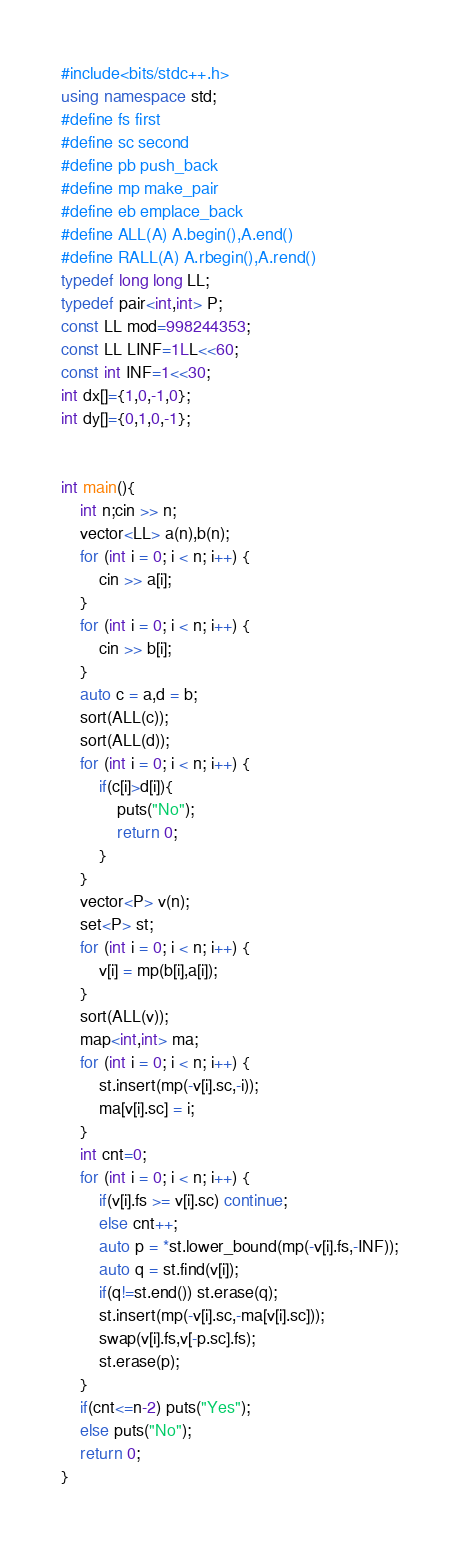<code> <loc_0><loc_0><loc_500><loc_500><_C++_>#include<bits/stdc++.h>
using namespace std;
#define fs first
#define sc second
#define pb push_back
#define mp make_pair
#define eb emplace_back
#define ALL(A) A.begin(),A.end()
#define RALL(A) A.rbegin(),A.rend()
typedef long long LL;
typedef pair<int,int> P;
const LL mod=998244353;
const LL LINF=1LL<<60;
const int INF=1<<30;
int dx[]={1,0,-1,0};
int dy[]={0,1,0,-1};


int main(){
    int n;cin >> n;
    vector<LL> a(n),b(n);
    for (int i = 0; i < n; i++) {
        cin >> a[i];
    }
    for (int i = 0; i < n; i++) {
        cin >> b[i];
    }
    auto c = a,d = b;
    sort(ALL(c));
    sort(ALL(d));
    for (int i = 0; i < n; i++) {
        if(c[i]>d[i]){
            puts("No");
            return 0;
        }
    }
    vector<P> v(n);
    set<P> st;
    for (int i = 0; i < n; i++) {
        v[i] = mp(b[i],a[i]);
    }
    sort(ALL(v));
    map<int,int> ma;
    for (int i = 0; i < n; i++) {
        st.insert(mp(-v[i].sc,-i));
        ma[v[i].sc] = i;
    }
    int cnt=0;
    for (int i = 0; i < n; i++) {
        if(v[i].fs >= v[i].sc) continue;
        else cnt++;
        auto p = *st.lower_bound(mp(-v[i].fs,-INF));
        auto q = st.find(v[i]);
        if(q!=st.end()) st.erase(q);
        st.insert(mp(-v[i].sc,-ma[v[i].sc]));
        swap(v[i].fs,v[-p.sc].fs);
        st.erase(p);
    }
    if(cnt<=n-2) puts("Yes");
    else puts("No");
    return 0;
}
</code> 